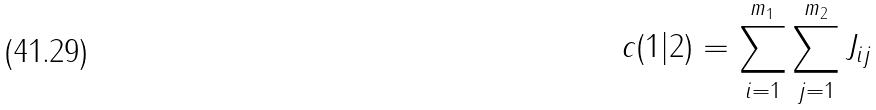Convert formula to latex. <formula><loc_0><loc_0><loc_500><loc_500>c ( 1 | 2 ) = \sum _ { i = 1 } ^ { m _ { 1 } } \sum _ { j = 1 } ^ { m _ { 2 } } J _ { i j }</formula> 